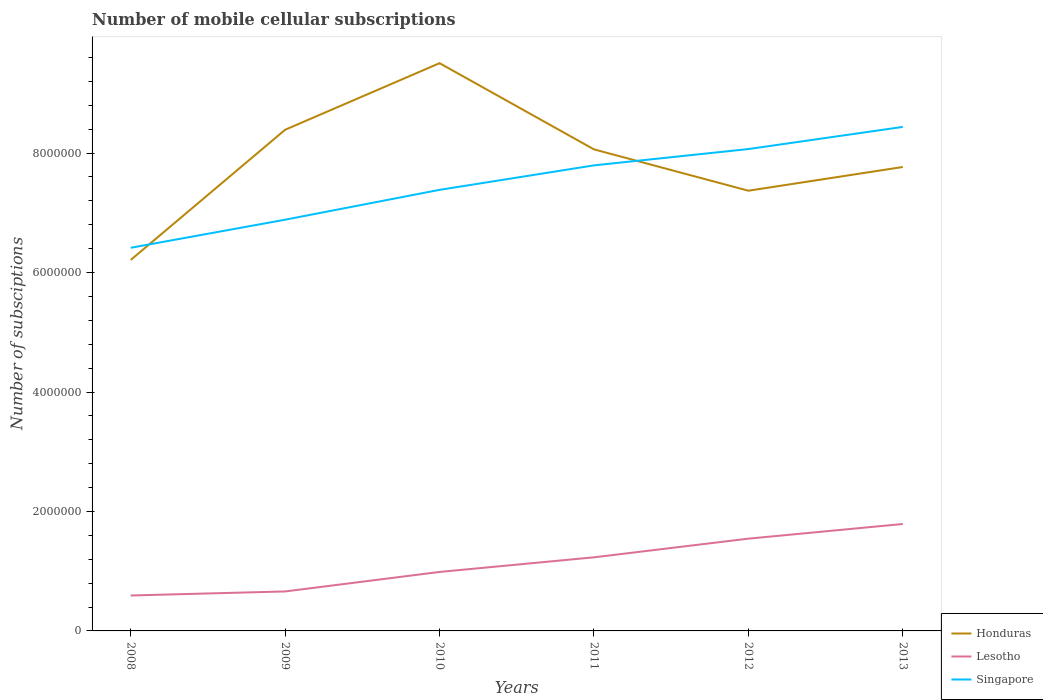Across all years, what is the maximum number of mobile cellular subscriptions in Honduras?
Provide a succinct answer. 6.21e+06. What is the total number of mobile cellular subscriptions in Honduras in the graph?
Give a very brief answer. -3.97e+05. What is the difference between the highest and the second highest number of mobile cellular subscriptions in Lesotho?
Your answer should be very brief. 1.20e+06. Is the number of mobile cellular subscriptions in Honduras strictly greater than the number of mobile cellular subscriptions in Lesotho over the years?
Your answer should be very brief. No. How many lines are there?
Provide a short and direct response. 3. Where does the legend appear in the graph?
Offer a very short reply. Bottom right. How many legend labels are there?
Keep it short and to the point. 3. What is the title of the graph?
Ensure brevity in your answer.  Number of mobile cellular subscriptions. Does "Austria" appear as one of the legend labels in the graph?
Keep it short and to the point. No. What is the label or title of the Y-axis?
Provide a short and direct response. Number of subsciptions. What is the Number of subsciptions of Honduras in 2008?
Ensure brevity in your answer.  6.21e+06. What is the Number of subsciptions of Lesotho in 2008?
Your response must be concise. 5.93e+05. What is the Number of subsciptions of Singapore in 2008?
Ensure brevity in your answer.  6.41e+06. What is the Number of subsciptions of Honduras in 2009?
Provide a succinct answer. 8.39e+06. What is the Number of subsciptions of Lesotho in 2009?
Your answer should be very brief. 6.61e+05. What is the Number of subsciptions of Singapore in 2009?
Offer a very short reply. 6.88e+06. What is the Number of subsciptions of Honduras in 2010?
Make the answer very short. 9.51e+06. What is the Number of subsciptions in Lesotho in 2010?
Give a very brief answer. 9.87e+05. What is the Number of subsciptions in Singapore in 2010?
Give a very brief answer. 7.38e+06. What is the Number of subsciptions in Honduras in 2011?
Your answer should be very brief. 8.06e+06. What is the Number of subsciptions of Lesotho in 2011?
Your answer should be very brief. 1.23e+06. What is the Number of subsciptions in Singapore in 2011?
Give a very brief answer. 7.79e+06. What is the Number of subsciptions in Honduras in 2012?
Give a very brief answer. 7.37e+06. What is the Number of subsciptions of Lesotho in 2012?
Offer a terse response. 1.54e+06. What is the Number of subsciptions of Singapore in 2012?
Keep it short and to the point. 8.07e+06. What is the Number of subsciptions in Honduras in 2013?
Provide a succinct answer. 7.77e+06. What is the Number of subsciptions in Lesotho in 2013?
Provide a succinct answer. 1.79e+06. What is the Number of subsciptions in Singapore in 2013?
Provide a short and direct response. 8.44e+06. Across all years, what is the maximum Number of subsciptions of Honduras?
Provide a succinct answer. 9.51e+06. Across all years, what is the maximum Number of subsciptions in Lesotho?
Make the answer very short. 1.79e+06. Across all years, what is the maximum Number of subsciptions of Singapore?
Keep it short and to the point. 8.44e+06. Across all years, what is the minimum Number of subsciptions in Honduras?
Ensure brevity in your answer.  6.21e+06. Across all years, what is the minimum Number of subsciptions of Lesotho?
Provide a succinct answer. 5.93e+05. Across all years, what is the minimum Number of subsciptions of Singapore?
Keep it short and to the point. 6.41e+06. What is the total Number of subsciptions in Honduras in the graph?
Ensure brevity in your answer.  4.73e+07. What is the total Number of subsciptions in Lesotho in the graph?
Provide a short and direct response. 6.81e+06. What is the total Number of subsciptions in Singapore in the graph?
Provide a short and direct response. 4.50e+07. What is the difference between the Number of subsciptions in Honduras in 2008 and that in 2009?
Keep it short and to the point. -2.18e+06. What is the difference between the Number of subsciptions of Lesotho in 2008 and that in 2009?
Provide a succinct answer. -6.78e+04. What is the difference between the Number of subsciptions of Singapore in 2008 and that in 2009?
Provide a short and direct response. -4.70e+05. What is the difference between the Number of subsciptions of Honduras in 2008 and that in 2010?
Give a very brief answer. -3.29e+06. What is the difference between the Number of subsciptions in Lesotho in 2008 and that in 2010?
Your answer should be compact. -3.94e+05. What is the difference between the Number of subsciptions of Singapore in 2008 and that in 2010?
Your answer should be very brief. -9.70e+05. What is the difference between the Number of subsciptions of Honduras in 2008 and that in 2011?
Your answer should be compact. -1.85e+06. What is the difference between the Number of subsciptions in Lesotho in 2008 and that in 2011?
Provide a succinct answer. -6.39e+05. What is the difference between the Number of subsciptions of Singapore in 2008 and that in 2011?
Provide a short and direct response. -1.38e+06. What is the difference between the Number of subsciptions in Honduras in 2008 and that in 2012?
Provide a succinct answer. -1.16e+06. What is the difference between the Number of subsciptions in Lesotho in 2008 and that in 2012?
Provide a succinct answer. -9.52e+05. What is the difference between the Number of subsciptions of Singapore in 2008 and that in 2012?
Provide a short and direct response. -1.65e+06. What is the difference between the Number of subsciptions of Honduras in 2008 and that in 2013?
Give a very brief answer. -1.56e+06. What is the difference between the Number of subsciptions of Lesotho in 2008 and that in 2013?
Your response must be concise. -1.20e+06. What is the difference between the Number of subsciptions in Singapore in 2008 and that in 2013?
Your answer should be very brief. -2.02e+06. What is the difference between the Number of subsciptions in Honduras in 2009 and that in 2010?
Your response must be concise. -1.11e+06. What is the difference between the Number of subsciptions of Lesotho in 2009 and that in 2010?
Your response must be concise. -3.26e+05. What is the difference between the Number of subsciptions in Singapore in 2009 and that in 2010?
Ensure brevity in your answer.  -5.00e+05. What is the difference between the Number of subsciptions of Honduras in 2009 and that in 2011?
Your answer should be compact. 3.29e+05. What is the difference between the Number of subsciptions of Lesotho in 2009 and that in 2011?
Offer a terse response. -5.71e+05. What is the difference between the Number of subsciptions in Singapore in 2009 and that in 2011?
Ensure brevity in your answer.  -9.10e+05. What is the difference between the Number of subsciptions in Honduras in 2009 and that in 2012?
Provide a succinct answer. 1.02e+06. What is the difference between the Number of subsciptions of Lesotho in 2009 and that in 2012?
Make the answer very short. -8.84e+05. What is the difference between the Number of subsciptions in Singapore in 2009 and that in 2012?
Provide a short and direct response. -1.18e+06. What is the difference between the Number of subsciptions in Honduras in 2009 and that in 2013?
Your response must be concise. 6.24e+05. What is the difference between the Number of subsciptions of Lesotho in 2009 and that in 2013?
Give a very brief answer. -1.13e+06. What is the difference between the Number of subsciptions in Singapore in 2009 and that in 2013?
Provide a succinct answer. -1.55e+06. What is the difference between the Number of subsciptions of Honduras in 2010 and that in 2011?
Keep it short and to the point. 1.44e+06. What is the difference between the Number of subsciptions in Lesotho in 2010 and that in 2011?
Keep it short and to the point. -2.45e+05. What is the difference between the Number of subsciptions in Singapore in 2010 and that in 2011?
Your response must be concise. -4.10e+05. What is the difference between the Number of subsciptions of Honduras in 2010 and that in 2012?
Give a very brief answer. 2.14e+06. What is the difference between the Number of subsciptions of Lesotho in 2010 and that in 2012?
Your response must be concise. -5.57e+05. What is the difference between the Number of subsciptions in Singapore in 2010 and that in 2012?
Ensure brevity in your answer.  -6.83e+05. What is the difference between the Number of subsciptions of Honduras in 2010 and that in 2013?
Offer a terse response. 1.74e+06. What is the difference between the Number of subsciptions of Lesotho in 2010 and that in 2013?
Your answer should be very brief. -8.03e+05. What is the difference between the Number of subsciptions of Singapore in 2010 and that in 2013?
Ensure brevity in your answer.  -1.05e+06. What is the difference between the Number of subsciptions in Honduras in 2011 and that in 2012?
Provide a succinct answer. 6.92e+05. What is the difference between the Number of subsciptions in Lesotho in 2011 and that in 2012?
Your answer should be very brief. -3.12e+05. What is the difference between the Number of subsciptions in Singapore in 2011 and that in 2012?
Give a very brief answer. -2.73e+05. What is the difference between the Number of subsciptions of Honduras in 2011 and that in 2013?
Provide a succinct answer. 2.95e+05. What is the difference between the Number of subsciptions of Lesotho in 2011 and that in 2013?
Your response must be concise. -5.58e+05. What is the difference between the Number of subsciptions in Singapore in 2011 and that in 2013?
Keep it short and to the point. -6.44e+05. What is the difference between the Number of subsciptions in Honduras in 2012 and that in 2013?
Make the answer very short. -3.97e+05. What is the difference between the Number of subsciptions in Lesotho in 2012 and that in 2013?
Your response must be concise. -2.45e+05. What is the difference between the Number of subsciptions in Singapore in 2012 and that in 2013?
Your answer should be very brief. -3.70e+05. What is the difference between the Number of subsciptions in Honduras in 2008 and the Number of subsciptions in Lesotho in 2009?
Provide a short and direct response. 5.55e+06. What is the difference between the Number of subsciptions of Honduras in 2008 and the Number of subsciptions of Singapore in 2009?
Provide a succinct answer. -6.74e+05. What is the difference between the Number of subsciptions in Lesotho in 2008 and the Number of subsciptions in Singapore in 2009?
Your response must be concise. -6.29e+06. What is the difference between the Number of subsciptions in Honduras in 2008 and the Number of subsciptions in Lesotho in 2010?
Give a very brief answer. 5.22e+06. What is the difference between the Number of subsciptions of Honduras in 2008 and the Number of subsciptions of Singapore in 2010?
Keep it short and to the point. -1.17e+06. What is the difference between the Number of subsciptions in Lesotho in 2008 and the Number of subsciptions in Singapore in 2010?
Your response must be concise. -6.79e+06. What is the difference between the Number of subsciptions in Honduras in 2008 and the Number of subsciptions in Lesotho in 2011?
Your response must be concise. 4.98e+06. What is the difference between the Number of subsciptions of Honduras in 2008 and the Number of subsciptions of Singapore in 2011?
Give a very brief answer. -1.58e+06. What is the difference between the Number of subsciptions in Lesotho in 2008 and the Number of subsciptions in Singapore in 2011?
Give a very brief answer. -7.20e+06. What is the difference between the Number of subsciptions of Honduras in 2008 and the Number of subsciptions of Lesotho in 2012?
Offer a terse response. 4.67e+06. What is the difference between the Number of subsciptions of Honduras in 2008 and the Number of subsciptions of Singapore in 2012?
Make the answer very short. -1.86e+06. What is the difference between the Number of subsciptions in Lesotho in 2008 and the Number of subsciptions in Singapore in 2012?
Provide a short and direct response. -7.47e+06. What is the difference between the Number of subsciptions of Honduras in 2008 and the Number of subsciptions of Lesotho in 2013?
Keep it short and to the point. 4.42e+06. What is the difference between the Number of subsciptions in Honduras in 2008 and the Number of subsciptions in Singapore in 2013?
Provide a short and direct response. -2.23e+06. What is the difference between the Number of subsciptions in Lesotho in 2008 and the Number of subsciptions in Singapore in 2013?
Make the answer very short. -7.84e+06. What is the difference between the Number of subsciptions of Honduras in 2009 and the Number of subsciptions of Lesotho in 2010?
Give a very brief answer. 7.40e+06. What is the difference between the Number of subsciptions in Honduras in 2009 and the Number of subsciptions in Singapore in 2010?
Your answer should be compact. 1.01e+06. What is the difference between the Number of subsciptions of Lesotho in 2009 and the Number of subsciptions of Singapore in 2010?
Offer a very short reply. -6.72e+06. What is the difference between the Number of subsciptions in Honduras in 2009 and the Number of subsciptions in Lesotho in 2011?
Offer a very short reply. 7.16e+06. What is the difference between the Number of subsciptions in Honduras in 2009 and the Number of subsciptions in Singapore in 2011?
Your answer should be compact. 5.96e+05. What is the difference between the Number of subsciptions in Lesotho in 2009 and the Number of subsciptions in Singapore in 2011?
Ensure brevity in your answer.  -7.13e+06. What is the difference between the Number of subsciptions in Honduras in 2009 and the Number of subsciptions in Lesotho in 2012?
Make the answer very short. 6.85e+06. What is the difference between the Number of subsciptions in Honduras in 2009 and the Number of subsciptions in Singapore in 2012?
Offer a terse response. 3.23e+05. What is the difference between the Number of subsciptions of Lesotho in 2009 and the Number of subsciptions of Singapore in 2012?
Your answer should be compact. -7.41e+06. What is the difference between the Number of subsciptions in Honduras in 2009 and the Number of subsciptions in Lesotho in 2013?
Your answer should be compact. 6.60e+06. What is the difference between the Number of subsciptions in Honduras in 2009 and the Number of subsciptions in Singapore in 2013?
Keep it short and to the point. -4.73e+04. What is the difference between the Number of subsciptions of Lesotho in 2009 and the Number of subsciptions of Singapore in 2013?
Provide a succinct answer. -7.78e+06. What is the difference between the Number of subsciptions of Honduras in 2010 and the Number of subsciptions of Lesotho in 2011?
Provide a succinct answer. 8.27e+06. What is the difference between the Number of subsciptions of Honduras in 2010 and the Number of subsciptions of Singapore in 2011?
Provide a succinct answer. 1.71e+06. What is the difference between the Number of subsciptions in Lesotho in 2010 and the Number of subsciptions in Singapore in 2011?
Ensure brevity in your answer.  -6.81e+06. What is the difference between the Number of subsciptions in Honduras in 2010 and the Number of subsciptions in Lesotho in 2012?
Provide a short and direct response. 7.96e+06. What is the difference between the Number of subsciptions of Honduras in 2010 and the Number of subsciptions of Singapore in 2012?
Provide a succinct answer. 1.44e+06. What is the difference between the Number of subsciptions in Lesotho in 2010 and the Number of subsciptions in Singapore in 2012?
Your answer should be very brief. -7.08e+06. What is the difference between the Number of subsciptions of Honduras in 2010 and the Number of subsciptions of Lesotho in 2013?
Keep it short and to the point. 7.71e+06. What is the difference between the Number of subsciptions of Honduras in 2010 and the Number of subsciptions of Singapore in 2013?
Provide a succinct answer. 1.07e+06. What is the difference between the Number of subsciptions of Lesotho in 2010 and the Number of subsciptions of Singapore in 2013?
Offer a terse response. -7.45e+06. What is the difference between the Number of subsciptions in Honduras in 2011 and the Number of subsciptions in Lesotho in 2012?
Your answer should be very brief. 6.52e+06. What is the difference between the Number of subsciptions in Honduras in 2011 and the Number of subsciptions in Singapore in 2012?
Make the answer very short. -5371. What is the difference between the Number of subsciptions of Lesotho in 2011 and the Number of subsciptions of Singapore in 2012?
Offer a very short reply. -6.84e+06. What is the difference between the Number of subsciptions in Honduras in 2011 and the Number of subsciptions in Lesotho in 2013?
Provide a succinct answer. 6.27e+06. What is the difference between the Number of subsciptions in Honduras in 2011 and the Number of subsciptions in Singapore in 2013?
Offer a very short reply. -3.76e+05. What is the difference between the Number of subsciptions of Lesotho in 2011 and the Number of subsciptions of Singapore in 2013?
Your response must be concise. -7.21e+06. What is the difference between the Number of subsciptions in Honduras in 2012 and the Number of subsciptions in Lesotho in 2013?
Your answer should be compact. 5.58e+06. What is the difference between the Number of subsciptions of Honduras in 2012 and the Number of subsciptions of Singapore in 2013?
Provide a succinct answer. -1.07e+06. What is the difference between the Number of subsciptions of Lesotho in 2012 and the Number of subsciptions of Singapore in 2013?
Your answer should be very brief. -6.89e+06. What is the average Number of subsciptions in Honduras per year?
Offer a terse response. 7.88e+06. What is the average Number of subsciptions of Lesotho per year?
Your response must be concise. 1.13e+06. What is the average Number of subsciptions in Singapore per year?
Offer a terse response. 7.50e+06. In the year 2008, what is the difference between the Number of subsciptions of Honduras and Number of subsciptions of Lesotho?
Offer a terse response. 5.62e+06. In the year 2008, what is the difference between the Number of subsciptions in Honduras and Number of subsciptions in Singapore?
Keep it short and to the point. -2.04e+05. In the year 2008, what is the difference between the Number of subsciptions in Lesotho and Number of subsciptions in Singapore?
Provide a short and direct response. -5.82e+06. In the year 2009, what is the difference between the Number of subsciptions of Honduras and Number of subsciptions of Lesotho?
Ensure brevity in your answer.  7.73e+06. In the year 2009, what is the difference between the Number of subsciptions in Honduras and Number of subsciptions in Singapore?
Keep it short and to the point. 1.51e+06. In the year 2009, what is the difference between the Number of subsciptions of Lesotho and Number of subsciptions of Singapore?
Your answer should be compact. -6.22e+06. In the year 2010, what is the difference between the Number of subsciptions of Honduras and Number of subsciptions of Lesotho?
Make the answer very short. 8.52e+06. In the year 2010, what is the difference between the Number of subsciptions in Honduras and Number of subsciptions in Singapore?
Give a very brief answer. 2.12e+06. In the year 2010, what is the difference between the Number of subsciptions in Lesotho and Number of subsciptions in Singapore?
Provide a short and direct response. -6.40e+06. In the year 2011, what is the difference between the Number of subsciptions in Honduras and Number of subsciptions in Lesotho?
Keep it short and to the point. 6.83e+06. In the year 2011, what is the difference between the Number of subsciptions of Honduras and Number of subsciptions of Singapore?
Your answer should be compact. 2.68e+05. In the year 2011, what is the difference between the Number of subsciptions in Lesotho and Number of subsciptions in Singapore?
Provide a succinct answer. -6.56e+06. In the year 2012, what is the difference between the Number of subsciptions of Honduras and Number of subsciptions of Lesotho?
Your answer should be compact. 5.83e+06. In the year 2012, what is the difference between the Number of subsciptions in Honduras and Number of subsciptions in Singapore?
Your answer should be compact. -6.98e+05. In the year 2012, what is the difference between the Number of subsciptions in Lesotho and Number of subsciptions in Singapore?
Provide a short and direct response. -6.52e+06. In the year 2013, what is the difference between the Number of subsciptions of Honduras and Number of subsciptions of Lesotho?
Provide a short and direct response. 5.98e+06. In the year 2013, what is the difference between the Number of subsciptions in Honduras and Number of subsciptions in Singapore?
Provide a short and direct response. -6.71e+05. In the year 2013, what is the difference between the Number of subsciptions of Lesotho and Number of subsciptions of Singapore?
Your answer should be very brief. -6.65e+06. What is the ratio of the Number of subsciptions of Honduras in 2008 to that in 2009?
Your answer should be very brief. 0.74. What is the ratio of the Number of subsciptions of Lesotho in 2008 to that in 2009?
Offer a terse response. 0.9. What is the ratio of the Number of subsciptions in Singapore in 2008 to that in 2009?
Provide a succinct answer. 0.93. What is the ratio of the Number of subsciptions in Honduras in 2008 to that in 2010?
Ensure brevity in your answer.  0.65. What is the ratio of the Number of subsciptions of Lesotho in 2008 to that in 2010?
Provide a short and direct response. 0.6. What is the ratio of the Number of subsciptions of Singapore in 2008 to that in 2010?
Provide a succinct answer. 0.87. What is the ratio of the Number of subsciptions of Honduras in 2008 to that in 2011?
Offer a terse response. 0.77. What is the ratio of the Number of subsciptions of Lesotho in 2008 to that in 2011?
Your answer should be very brief. 0.48. What is the ratio of the Number of subsciptions of Singapore in 2008 to that in 2011?
Keep it short and to the point. 0.82. What is the ratio of the Number of subsciptions of Honduras in 2008 to that in 2012?
Offer a very short reply. 0.84. What is the ratio of the Number of subsciptions of Lesotho in 2008 to that in 2012?
Your response must be concise. 0.38. What is the ratio of the Number of subsciptions of Singapore in 2008 to that in 2012?
Give a very brief answer. 0.8. What is the ratio of the Number of subsciptions in Honduras in 2008 to that in 2013?
Provide a short and direct response. 0.8. What is the ratio of the Number of subsciptions in Lesotho in 2008 to that in 2013?
Your answer should be compact. 0.33. What is the ratio of the Number of subsciptions of Singapore in 2008 to that in 2013?
Ensure brevity in your answer.  0.76. What is the ratio of the Number of subsciptions of Honduras in 2009 to that in 2010?
Offer a very short reply. 0.88. What is the ratio of the Number of subsciptions in Lesotho in 2009 to that in 2010?
Provide a succinct answer. 0.67. What is the ratio of the Number of subsciptions of Singapore in 2009 to that in 2010?
Keep it short and to the point. 0.93. What is the ratio of the Number of subsciptions of Honduras in 2009 to that in 2011?
Ensure brevity in your answer.  1.04. What is the ratio of the Number of subsciptions of Lesotho in 2009 to that in 2011?
Give a very brief answer. 0.54. What is the ratio of the Number of subsciptions of Singapore in 2009 to that in 2011?
Ensure brevity in your answer.  0.88. What is the ratio of the Number of subsciptions in Honduras in 2009 to that in 2012?
Your answer should be very brief. 1.14. What is the ratio of the Number of subsciptions of Lesotho in 2009 to that in 2012?
Your response must be concise. 0.43. What is the ratio of the Number of subsciptions in Singapore in 2009 to that in 2012?
Your response must be concise. 0.85. What is the ratio of the Number of subsciptions of Honduras in 2009 to that in 2013?
Provide a short and direct response. 1.08. What is the ratio of the Number of subsciptions in Lesotho in 2009 to that in 2013?
Provide a short and direct response. 0.37. What is the ratio of the Number of subsciptions in Singapore in 2009 to that in 2013?
Your response must be concise. 0.82. What is the ratio of the Number of subsciptions of Honduras in 2010 to that in 2011?
Offer a terse response. 1.18. What is the ratio of the Number of subsciptions of Lesotho in 2010 to that in 2011?
Make the answer very short. 0.8. What is the ratio of the Number of subsciptions in Singapore in 2010 to that in 2011?
Provide a short and direct response. 0.95. What is the ratio of the Number of subsciptions in Honduras in 2010 to that in 2012?
Offer a very short reply. 1.29. What is the ratio of the Number of subsciptions of Lesotho in 2010 to that in 2012?
Keep it short and to the point. 0.64. What is the ratio of the Number of subsciptions in Singapore in 2010 to that in 2012?
Keep it short and to the point. 0.92. What is the ratio of the Number of subsciptions of Honduras in 2010 to that in 2013?
Provide a short and direct response. 1.22. What is the ratio of the Number of subsciptions in Lesotho in 2010 to that in 2013?
Your response must be concise. 0.55. What is the ratio of the Number of subsciptions of Singapore in 2010 to that in 2013?
Offer a very short reply. 0.88. What is the ratio of the Number of subsciptions in Honduras in 2011 to that in 2012?
Make the answer very short. 1.09. What is the ratio of the Number of subsciptions in Lesotho in 2011 to that in 2012?
Provide a short and direct response. 0.8. What is the ratio of the Number of subsciptions in Singapore in 2011 to that in 2012?
Give a very brief answer. 0.97. What is the ratio of the Number of subsciptions in Honduras in 2011 to that in 2013?
Make the answer very short. 1.04. What is the ratio of the Number of subsciptions in Lesotho in 2011 to that in 2013?
Give a very brief answer. 0.69. What is the ratio of the Number of subsciptions in Singapore in 2011 to that in 2013?
Offer a very short reply. 0.92. What is the ratio of the Number of subsciptions in Honduras in 2012 to that in 2013?
Give a very brief answer. 0.95. What is the ratio of the Number of subsciptions of Lesotho in 2012 to that in 2013?
Keep it short and to the point. 0.86. What is the ratio of the Number of subsciptions in Singapore in 2012 to that in 2013?
Offer a very short reply. 0.96. What is the difference between the highest and the second highest Number of subsciptions in Honduras?
Your response must be concise. 1.11e+06. What is the difference between the highest and the second highest Number of subsciptions in Lesotho?
Give a very brief answer. 2.45e+05. What is the difference between the highest and the second highest Number of subsciptions in Singapore?
Your answer should be very brief. 3.70e+05. What is the difference between the highest and the lowest Number of subsciptions of Honduras?
Provide a succinct answer. 3.29e+06. What is the difference between the highest and the lowest Number of subsciptions in Lesotho?
Ensure brevity in your answer.  1.20e+06. What is the difference between the highest and the lowest Number of subsciptions in Singapore?
Provide a succinct answer. 2.02e+06. 